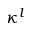Convert formula to latex. <formula><loc_0><loc_0><loc_500><loc_500>\kappa ^ { l }</formula> 